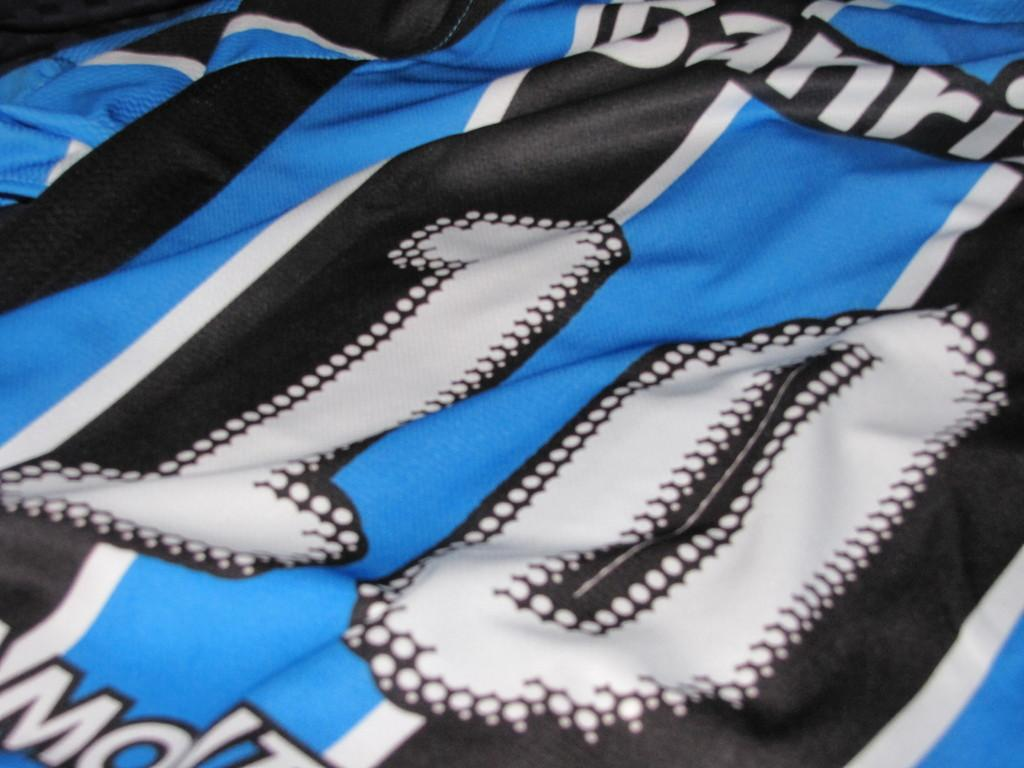<image>
Render a clear and concise summary of the photo. Blue and black jersey with the number 10 in white with black stitching. 